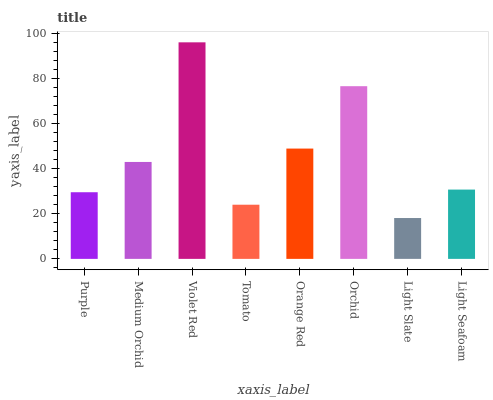Is Light Slate the minimum?
Answer yes or no. Yes. Is Violet Red the maximum?
Answer yes or no. Yes. Is Medium Orchid the minimum?
Answer yes or no. No. Is Medium Orchid the maximum?
Answer yes or no. No. Is Medium Orchid greater than Purple?
Answer yes or no. Yes. Is Purple less than Medium Orchid?
Answer yes or no. Yes. Is Purple greater than Medium Orchid?
Answer yes or no. No. Is Medium Orchid less than Purple?
Answer yes or no. No. Is Medium Orchid the high median?
Answer yes or no. Yes. Is Light Seafoam the low median?
Answer yes or no. Yes. Is Tomato the high median?
Answer yes or no. No. Is Light Slate the low median?
Answer yes or no. No. 